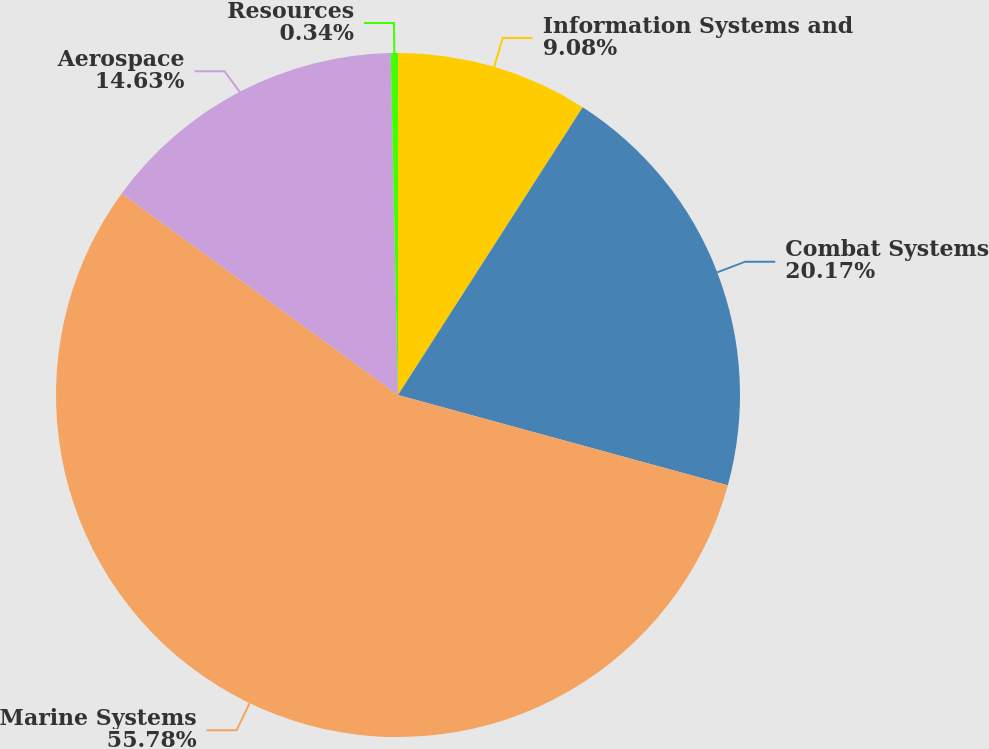Convert chart to OTSL. <chart><loc_0><loc_0><loc_500><loc_500><pie_chart><fcel>Information Systems and<fcel>Combat Systems<fcel>Marine Systems<fcel>Aerospace<fcel>Resources<nl><fcel>9.08%<fcel>20.17%<fcel>55.78%<fcel>14.63%<fcel>0.34%<nl></chart> 